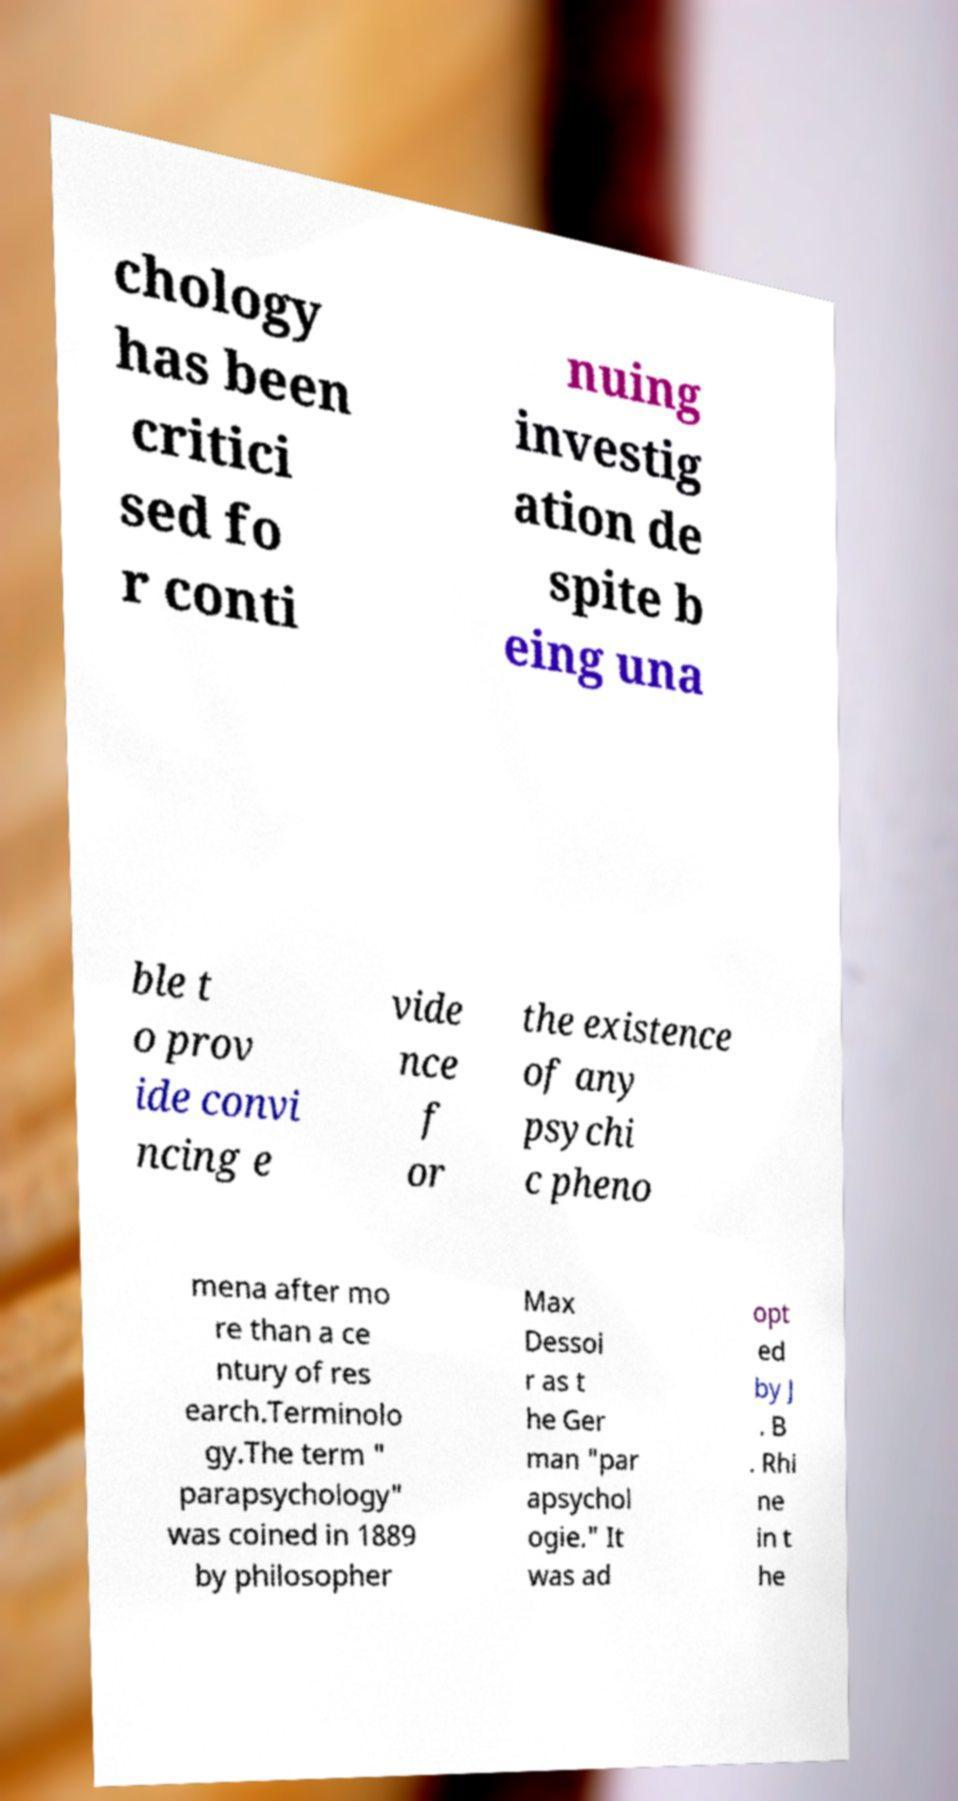There's text embedded in this image that I need extracted. Can you transcribe it verbatim? chology has been critici sed fo r conti nuing investig ation de spite b eing una ble t o prov ide convi ncing e vide nce f or the existence of any psychi c pheno mena after mo re than a ce ntury of res earch.Terminolo gy.The term " parapsychology" was coined in 1889 by philosopher Max Dessoi r as t he Ger man "par apsychol ogie." It was ad opt ed by J . B . Rhi ne in t he 